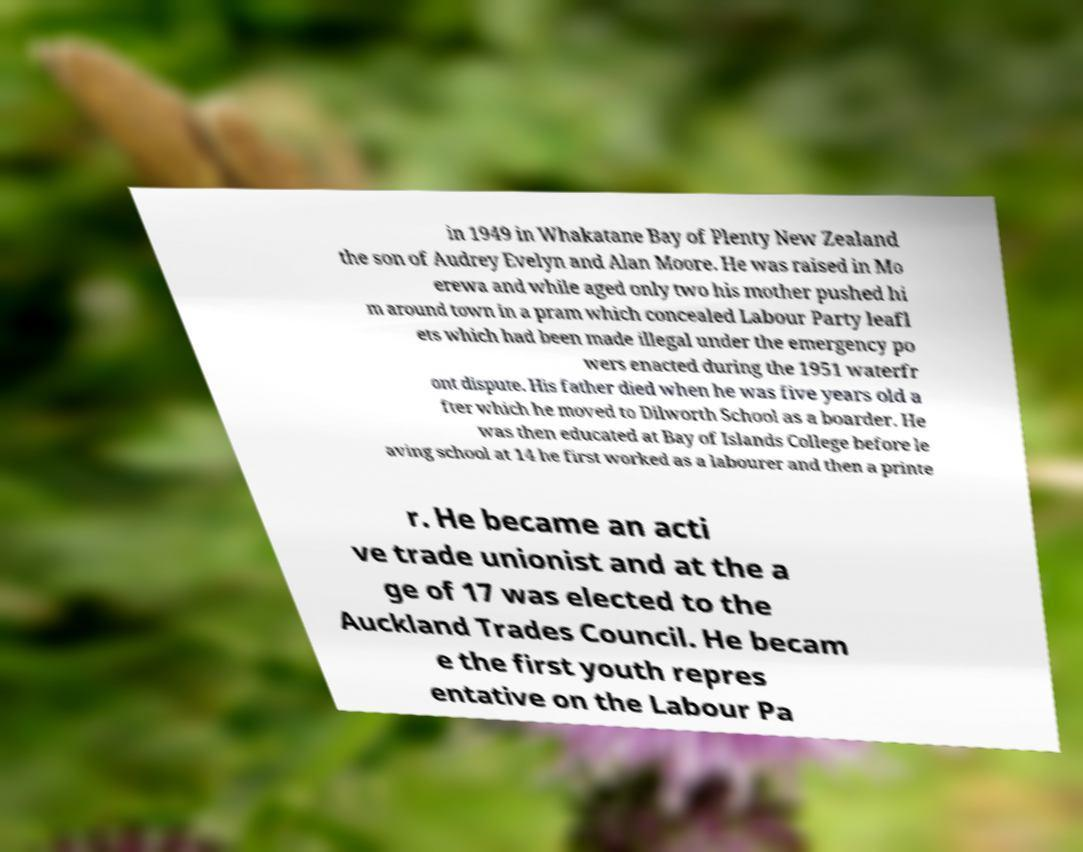What messages or text are displayed in this image? I need them in a readable, typed format. in 1949 in Whakatane Bay of Plenty New Zealand the son of Audrey Evelyn and Alan Moore. He was raised in Mo erewa and while aged only two his mother pushed hi m around town in a pram which concealed Labour Party leafl ets which had been made illegal under the emergency po wers enacted during the 1951 waterfr ont dispute. His father died when he was five years old a fter which he moved to Dilworth School as a boarder. He was then educated at Bay of Islands College before le aving school at 14 he first worked as a labourer and then a printe r. He became an acti ve trade unionist and at the a ge of 17 was elected to the Auckland Trades Council. He becam e the first youth repres entative on the Labour Pa 